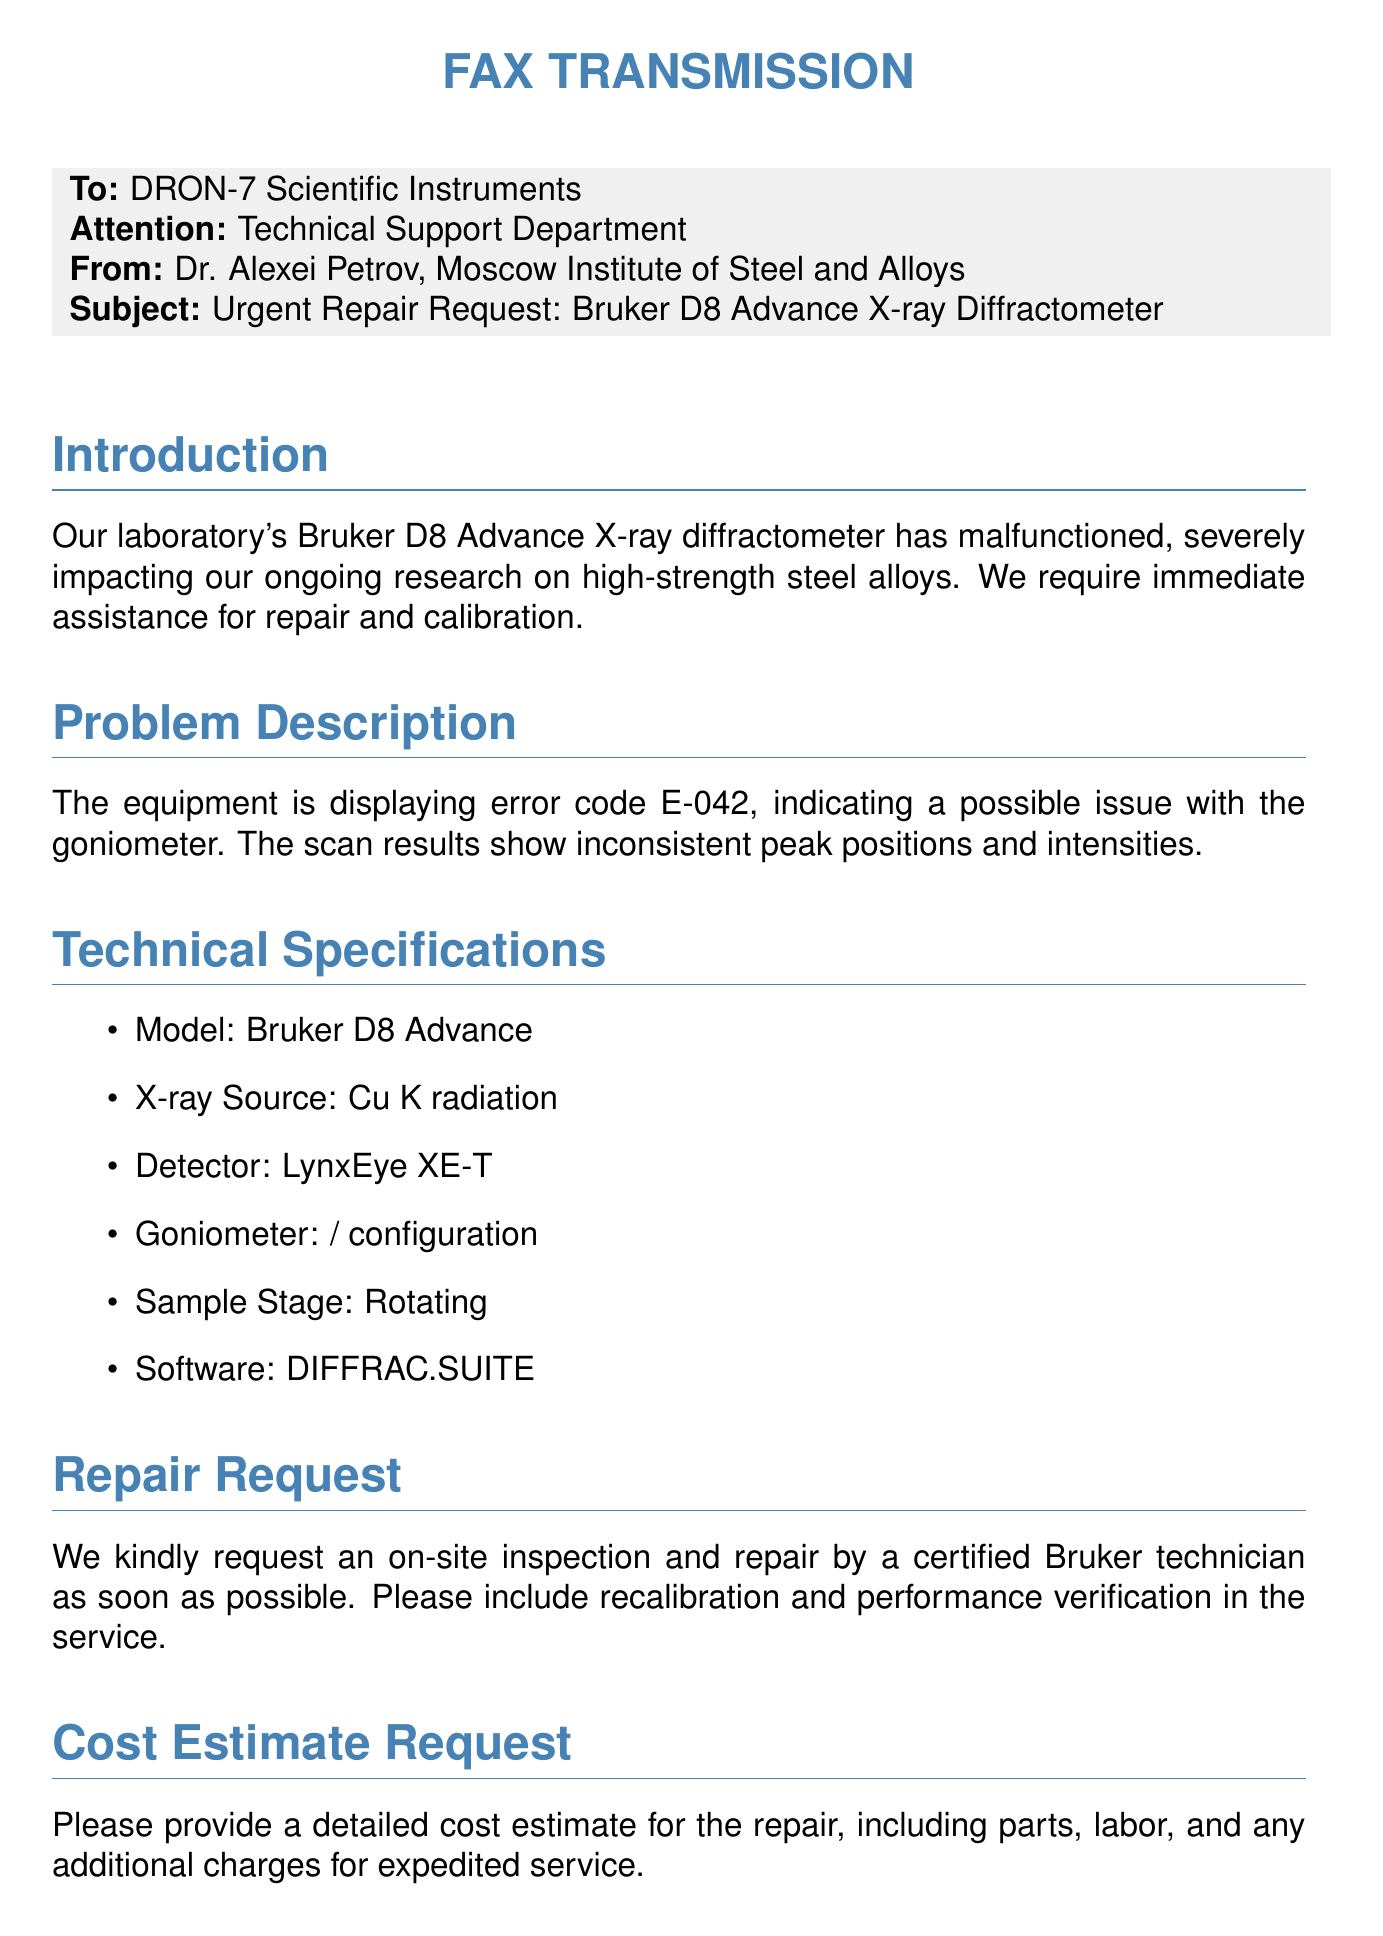What is the subject of the fax? The subject line of the fax indicates the critical issue being addressed is regarding the repair of the diffractometer.
Answer: Urgent Repair Request: Bruker D8 Advance X-ray Diffractometer Who is the sender of the fax? The fax includes a header with the name of the sender.
Answer: Dr. Alexei Petrov What is the error code displayed by the equipment? The problem description specifies the error code as being a key issue in the malfunction.
Answer: E-042 What model of diffractometer is mentioned? The technical specifications section lists the model of the equipment in question.
Answer: Bruker D8 Advance What type of X-ray source does the diffractometer use? The specifications directly outline the type of X-ray source utilized by the instrument.
Answer: Cu Kα radiation What service is specifically requested for the diffractometer? The repair request section outlines the type of visit and actions that need to be taken regarding the equipment.
Answer: On-site inspection and repair What is requested in addition to the repair? The closing of the repair request explicitly mentions additional services anticipated alongside the repair.
Answer: Recalibration and performance verification What contact method is provided for additional information? The contact section offers a way to reach out for further details or to arrange a service visit.
Answer: +7 (495) 955-0032 What is the primary issue being faced by the laboratory? The introduction of the fax lays out the impact of the malfunction on laboratory operations clearly.
Answer: Malfunction of the X-ray diffractometer 